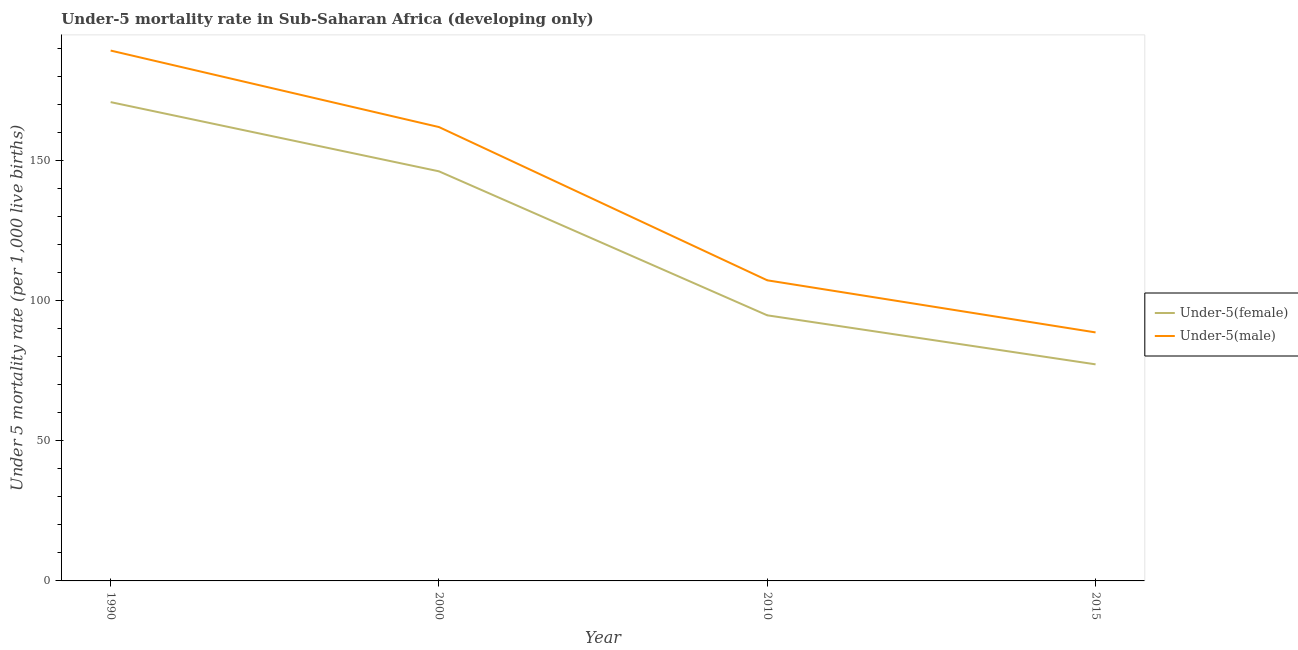Does the line corresponding to under-5 male mortality rate intersect with the line corresponding to under-5 female mortality rate?
Offer a terse response. No. Is the number of lines equal to the number of legend labels?
Make the answer very short. Yes. What is the under-5 female mortality rate in 2000?
Give a very brief answer. 146.2. Across all years, what is the maximum under-5 female mortality rate?
Provide a succinct answer. 170.9. Across all years, what is the minimum under-5 male mortality rate?
Keep it short and to the point. 88.7. In which year was the under-5 female mortality rate maximum?
Provide a short and direct response. 1990. In which year was the under-5 female mortality rate minimum?
Provide a short and direct response. 2015. What is the total under-5 male mortality rate in the graph?
Keep it short and to the point. 547.3. What is the difference between the under-5 male mortality rate in 1990 and that in 2000?
Make the answer very short. 27.3. What is the difference between the under-5 female mortality rate in 2015 and the under-5 male mortality rate in 1990?
Ensure brevity in your answer.  -112. What is the average under-5 female mortality rate per year?
Ensure brevity in your answer.  122.3. In the year 2000, what is the difference between the under-5 male mortality rate and under-5 female mortality rate?
Make the answer very short. 15.8. What is the ratio of the under-5 female mortality rate in 2010 to that in 2015?
Provide a succinct answer. 1.23. Is the under-5 female mortality rate in 1990 less than that in 2010?
Give a very brief answer. No. Is the difference between the under-5 female mortality rate in 2010 and 2015 greater than the difference between the under-5 male mortality rate in 2010 and 2015?
Provide a short and direct response. No. What is the difference between the highest and the second highest under-5 male mortality rate?
Your answer should be very brief. 27.3. What is the difference between the highest and the lowest under-5 female mortality rate?
Your answer should be compact. 93.6. Does the under-5 female mortality rate monotonically increase over the years?
Provide a short and direct response. No. Is the under-5 female mortality rate strictly greater than the under-5 male mortality rate over the years?
Ensure brevity in your answer.  No. How many lines are there?
Offer a very short reply. 2. What is the difference between two consecutive major ticks on the Y-axis?
Offer a terse response. 50. Does the graph contain grids?
Provide a succinct answer. No. How many legend labels are there?
Your answer should be compact. 2. How are the legend labels stacked?
Your response must be concise. Vertical. What is the title of the graph?
Provide a short and direct response. Under-5 mortality rate in Sub-Saharan Africa (developing only). What is the label or title of the Y-axis?
Provide a short and direct response. Under 5 mortality rate (per 1,0 live births). What is the Under 5 mortality rate (per 1,000 live births) in Under-5(female) in 1990?
Give a very brief answer. 170.9. What is the Under 5 mortality rate (per 1,000 live births) of Under-5(male) in 1990?
Your response must be concise. 189.3. What is the Under 5 mortality rate (per 1,000 live births) in Under-5(female) in 2000?
Provide a succinct answer. 146.2. What is the Under 5 mortality rate (per 1,000 live births) in Under-5(male) in 2000?
Your response must be concise. 162. What is the Under 5 mortality rate (per 1,000 live births) in Under-5(female) in 2010?
Give a very brief answer. 94.8. What is the Under 5 mortality rate (per 1,000 live births) in Under-5(male) in 2010?
Ensure brevity in your answer.  107.3. What is the Under 5 mortality rate (per 1,000 live births) in Under-5(female) in 2015?
Make the answer very short. 77.3. What is the Under 5 mortality rate (per 1,000 live births) of Under-5(male) in 2015?
Make the answer very short. 88.7. Across all years, what is the maximum Under 5 mortality rate (per 1,000 live births) of Under-5(female)?
Give a very brief answer. 170.9. Across all years, what is the maximum Under 5 mortality rate (per 1,000 live births) in Under-5(male)?
Ensure brevity in your answer.  189.3. Across all years, what is the minimum Under 5 mortality rate (per 1,000 live births) in Under-5(female)?
Your response must be concise. 77.3. Across all years, what is the minimum Under 5 mortality rate (per 1,000 live births) in Under-5(male)?
Make the answer very short. 88.7. What is the total Under 5 mortality rate (per 1,000 live births) of Under-5(female) in the graph?
Provide a short and direct response. 489.2. What is the total Under 5 mortality rate (per 1,000 live births) of Under-5(male) in the graph?
Provide a short and direct response. 547.3. What is the difference between the Under 5 mortality rate (per 1,000 live births) of Under-5(female) in 1990 and that in 2000?
Provide a succinct answer. 24.7. What is the difference between the Under 5 mortality rate (per 1,000 live births) in Under-5(male) in 1990 and that in 2000?
Offer a terse response. 27.3. What is the difference between the Under 5 mortality rate (per 1,000 live births) of Under-5(female) in 1990 and that in 2010?
Your response must be concise. 76.1. What is the difference between the Under 5 mortality rate (per 1,000 live births) of Under-5(male) in 1990 and that in 2010?
Offer a very short reply. 82. What is the difference between the Under 5 mortality rate (per 1,000 live births) in Under-5(female) in 1990 and that in 2015?
Ensure brevity in your answer.  93.6. What is the difference between the Under 5 mortality rate (per 1,000 live births) in Under-5(male) in 1990 and that in 2015?
Keep it short and to the point. 100.6. What is the difference between the Under 5 mortality rate (per 1,000 live births) of Under-5(female) in 2000 and that in 2010?
Keep it short and to the point. 51.4. What is the difference between the Under 5 mortality rate (per 1,000 live births) of Under-5(male) in 2000 and that in 2010?
Ensure brevity in your answer.  54.7. What is the difference between the Under 5 mortality rate (per 1,000 live births) of Under-5(female) in 2000 and that in 2015?
Give a very brief answer. 68.9. What is the difference between the Under 5 mortality rate (per 1,000 live births) of Under-5(male) in 2000 and that in 2015?
Offer a terse response. 73.3. What is the difference between the Under 5 mortality rate (per 1,000 live births) in Under-5(female) in 2010 and that in 2015?
Keep it short and to the point. 17.5. What is the difference between the Under 5 mortality rate (per 1,000 live births) of Under-5(female) in 1990 and the Under 5 mortality rate (per 1,000 live births) of Under-5(male) in 2010?
Your answer should be compact. 63.6. What is the difference between the Under 5 mortality rate (per 1,000 live births) of Under-5(female) in 1990 and the Under 5 mortality rate (per 1,000 live births) of Under-5(male) in 2015?
Make the answer very short. 82.2. What is the difference between the Under 5 mortality rate (per 1,000 live births) in Under-5(female) in 2000 and the Under 5 mortality rate (per 1,000 live births) in Under-5(male) in 2010?
Ensure brevity in your answer.  38.9. What is the difference between the Under 5 mortality rate (per 1,000 live births) in Under-5(female) in 2000 and the Under 5 mortality rate (per 1,000 live births) in Under-5(male) in 2015?
Provide a short and direct response. 57.5. What is the average Under 5 mortality rate (per 1,000 live births) in Under-5(female) per year?
Offer a very short reply. 122.3. What is the average Under 5 mortality rate (per 1,000 live births) in Under-5(male) per year?
Your answer should be compact. 136.82. In the year 1990, what is the difference between the Under 5 mortality rate (per 1,000 live births) in Under-5(female) and Under 5 mortality rate (per 1,000 live births) in Under-5(male)?
Give a very brief answer. -18.4. In the year 2000, what is the difference between the Under 5 mortality rate (per 1,000 live births) in Under-5(female) and Under 5 mortality rate (per 1,000 live births) in Under-5(male)?
Offer a terse response. -15.8. In the year 2015, what is the difference between the Under 5 mortality rate (per 1,000 live births) of Under-5(female) and Under 5 mortality rate (per 1,000 live births) of Under-5(male)?
Make the answer very short. -11.4. What is the ratio of the Under 5 mortality rate (per 1,000 live births) in Under-5(female) in 1990 to that in 2000?
Your answer should be very brief. 1.17. What is the ratio of the Under 5 mortality rate (per 1,000 live births) in Under-5(male) in 1990 to that in 2000?
Keep it short and to the point. 1.17. What is the ratio of the Under 5 mortality rate (per 1,000 live births) of Under-5(female) in 1990 to that in 2010?
Your response must be concise. 1.8. What is the ratio of the Under 5 mortality rate (per 1,000 live births) of Under-5(male) in 1990 to that in 2010?
Your answer should be very brief. 1.76. What is the ratio of the Under 5 mortality rate (per 1,000 live births) in Under-5(female) in 1990 to that in 2015?
Provide a short and direct response. 2.21. What is the ratio of the Under 5 mortality rate (per 1,000 live births) in Under-5(male) in 1990 to that in 2015?
Provide a short and direct response. 2.13. What is the ratio of the Under 5 mortality rate (per 1,000 live births) in Under-5(female) in 2000 to that in 2010?
Your response must be concise. 1.54. What is the ratio of the Under 5 mortality rate (per 1,000 live births) in Under-5(male) in 2000 to that in 2010?
Provide a short and direct response. 1.51. What is the ratio of the Under 5 mortality rate (per 1,000 live births) of Under-5(female) in 2000 to that in 2015?
Make the answer very short. 1.89. What is the ratio of the Under 5 mortality rate (per 1,000 live births) in Under-5(male) in 2000 to that in 2015?
Keep it short and to the point. 1.83. What is the ratio of the Under 5 mortality rate (per 1,000 live births) of Under-5(female) in 2010 to that in 2015?
Ensure brevity in your answer.  1.23. What is the ratio of the Under 5 mortality rate (per 1,000 live births) in Under-5(male) in 2010 to that in 2015?
Your answer should be compact. 1.21. What is the difference between the highest and the second highest Under 5 mortality rate (per 1,000 live births) in Under-5(female)?
Give a very brief answer. 24.7. What is the difference between the highest and the second highest Under 5 mortality rate (per 1,000 live births) of Under-5(male)?
Give a very brief answer. 27.3. What is the difference between the highest and the lowest Under 5 mortality rate (per 1,000 live births) in Under-5(female)?
Give a very brief answer. 93.6. What is the difference between the highest and the lowest Under 5 mortality rate (per 1,000 live births) in Under-5(male)?
Offer a terse response. 100.6. 